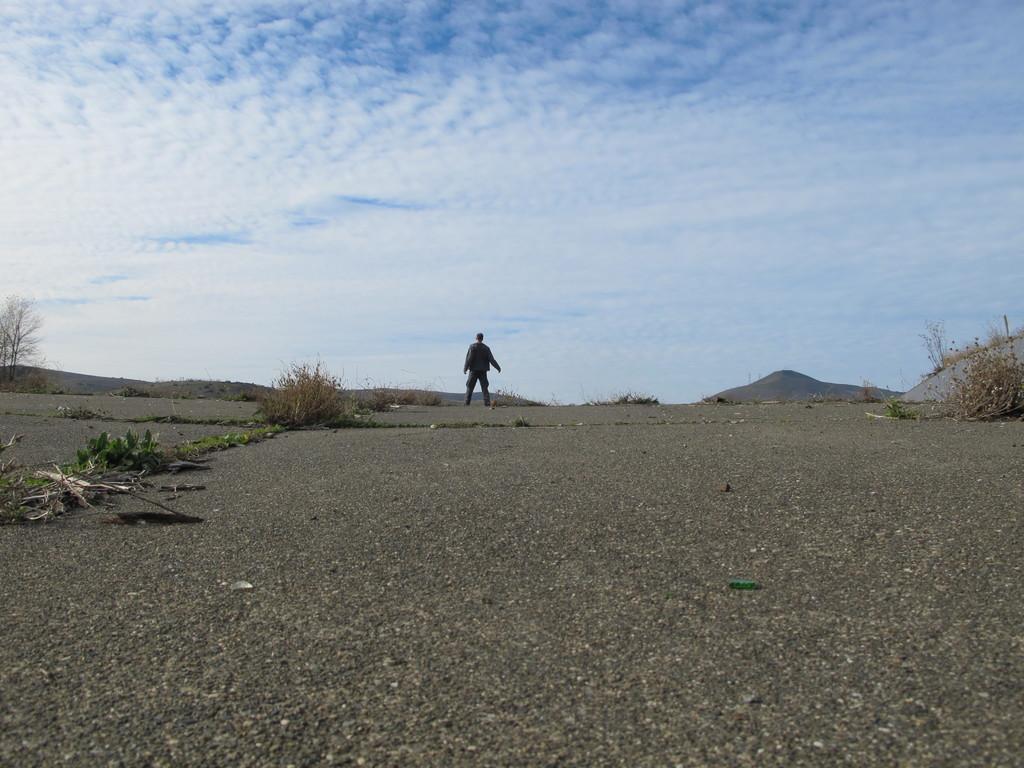How would you summarize this image in a sentence or two? In this picture we can see few plants and a person is standing in the middle of the image, in the background we can find hills and clouds. 